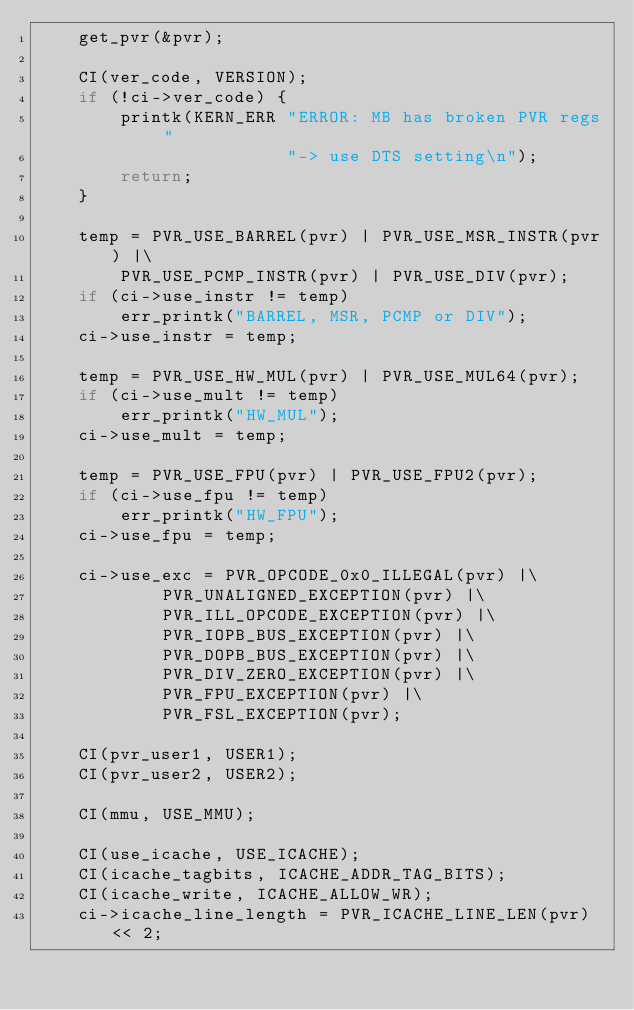Convert code to text. <code><loc_0><loc_0><loc_500><loc_500><_C_>	get_pvr(&pvr);

	CI(ver_code, VERSION);
	if (!ci->ver_code) {
		printk(KERN_ERR "ERROR: MB has broken PVR regs "
						"-> use DTS setting\n");
		return;
	}

	temp = PVR_USE_BARREL(pvr) | PVR_USE_MSR_INSTR(pvr) |\
		PVR_USE_PCMP_INSTR(pvr) | PVR_USE_DIV(pvr);
	if (ci->use_instr != temp)
		err_printk("BARREL, MSR, PCMP or DIV");
	ci->use_instr = temp;

	temp = PVR_USE_HW_MUL(pvr) | PVR_USE_MUL64(pvr);
	if (ci->use_mult != temp)
		err_printk("HW_MUL");
	ci->use_mult = temp;

	temp = PVR_USE_FPU(pvr) | PVR_USE_FPU2(pvr);
	if (ci->use_fpu != temp)
		err_printk("HW_FPU");
	ci->use_fpu = temp;

	ci->use_exc = PVR_OPCODE_0x0_ILLEGAL(pvr) |\
			PVR_UNALIGNED_EXCEPTION(pvr) |\
			PVR_ILL_OPCODE_EXCEPTION(pvr) |\
			PVR_IOPB_BUS_EXCEPTION(pvr) |\
			PVR_DOPB_BUS_EXCEPTION(pvr) |\
			PVR_DIV_ZERO_EXCEPTION(pvr) |\
			PVR_FPU_EXCEPTION(pvr) |\
			PVR_FSL_EXCEPTION(pvr);

	CI(pvr_user1, USER1);
	CI(pvr_user2, USER2);

	CI(mmu, USE_MMU);

	CI(use_icache, USE_ICACHE);
	CI(icache_tagbits, ICACHE_ADDR_TAG_BITS);
	CI(icache_write, ICACHE_ALLOW_WR);
	ci->icache_line_length = PVR_ICACHE_LINE_LEN(pvr) << 2;</code> 